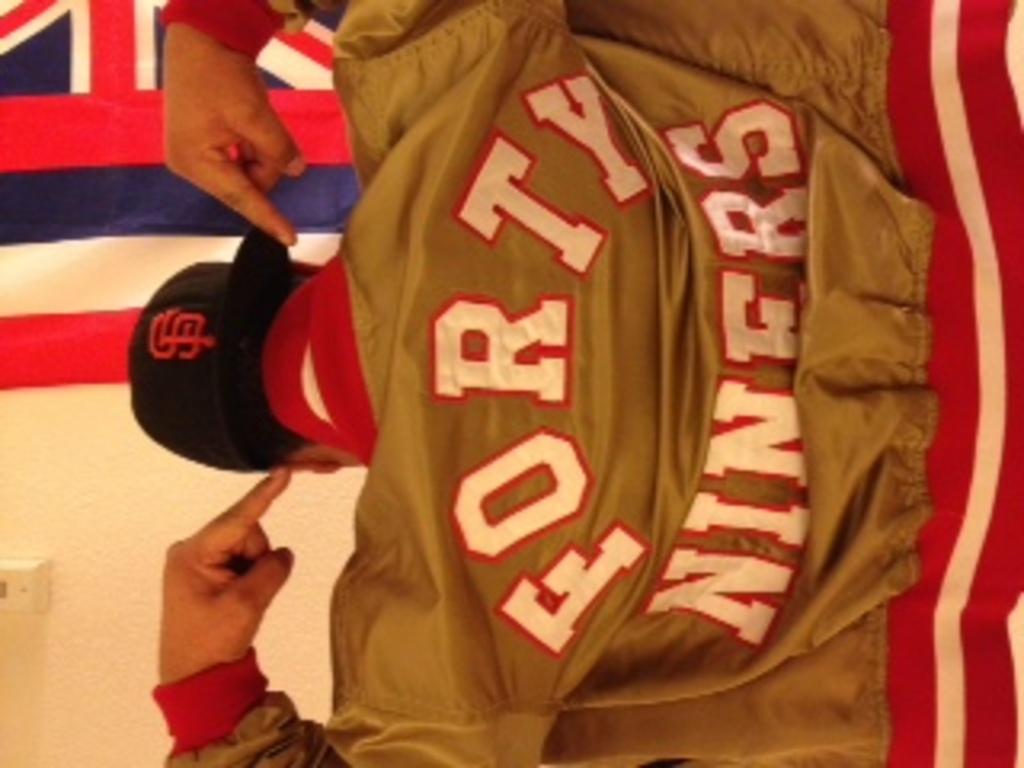What team is this guy a fan of?
Your answer should be compact. Forty niners. What are the letters on hat?
Offer a terse response. Sf. 